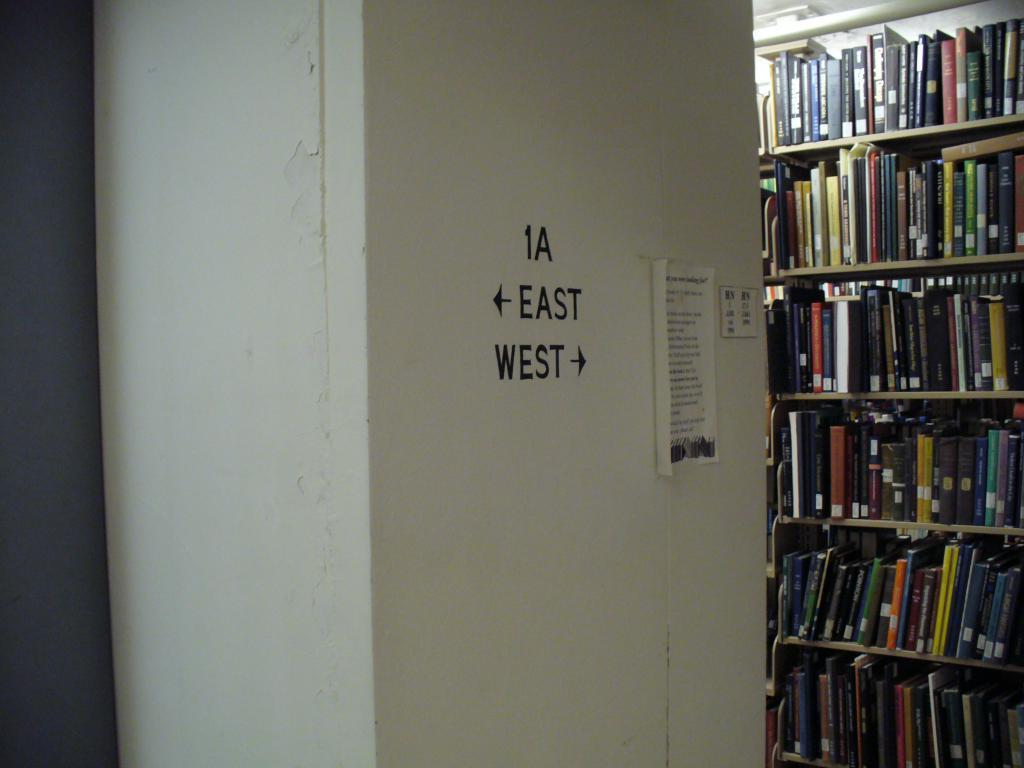<image>
Create a compact narrative representing the image presented. a wall with 1A on it pointing east and west 